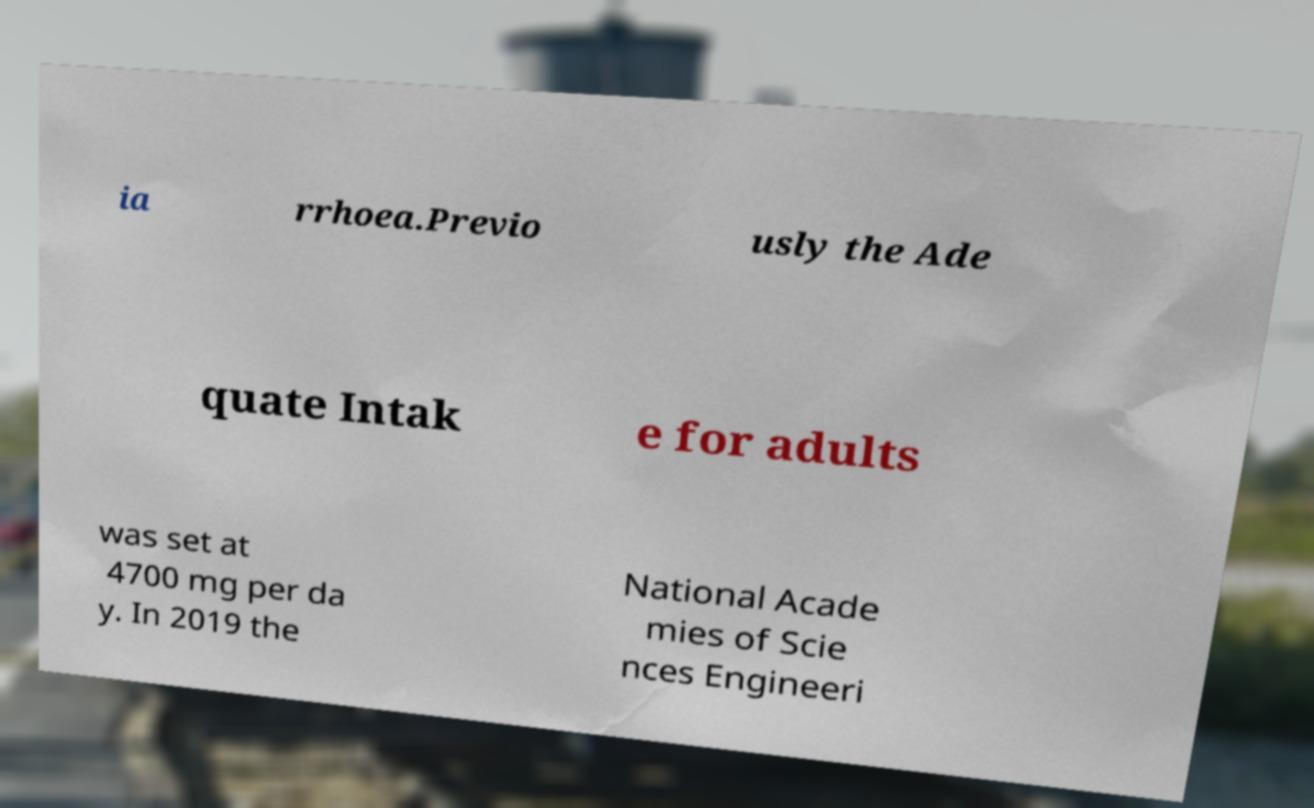What messages or text are displayed in this image? I need them in a readable, typed format. ia rrhoea.Previo usly the Ade quate Intak e for adults was set at 4700 mg per da y. In 2019 the National Acade mies of Scie nces Engineeri 